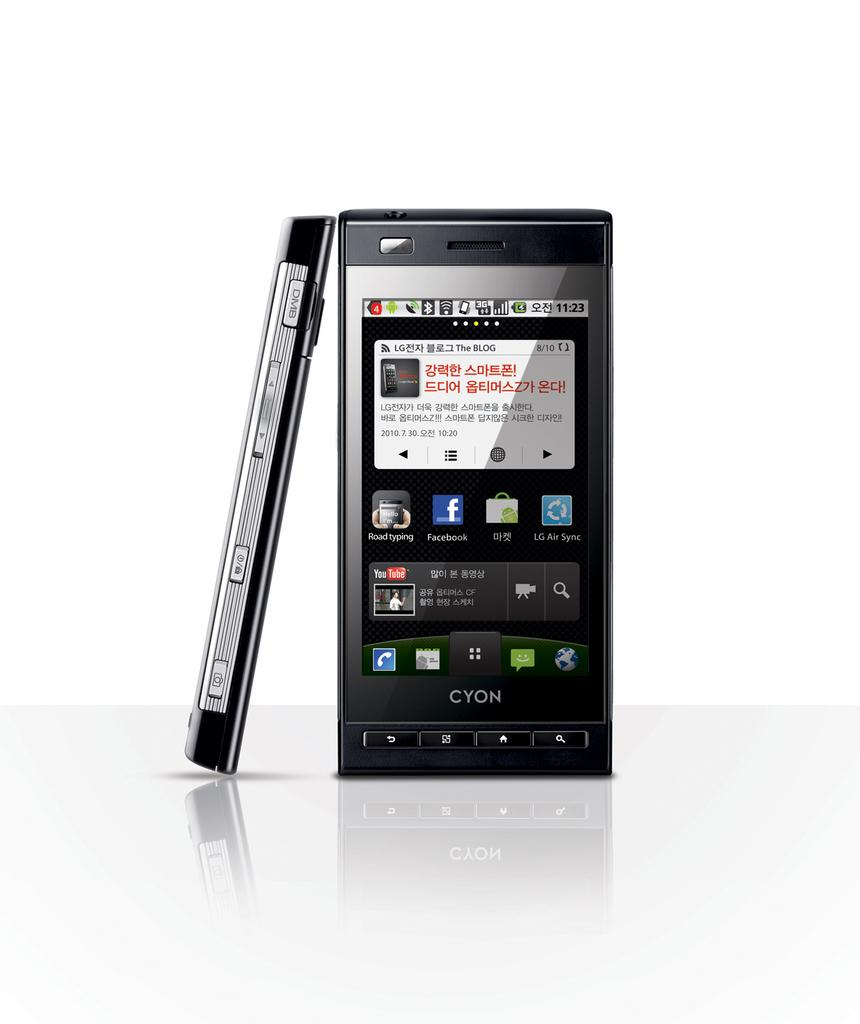Provide a one-sentence caption for the provided image. Two Cyon phones one is lending against the other with a white backgroud. 